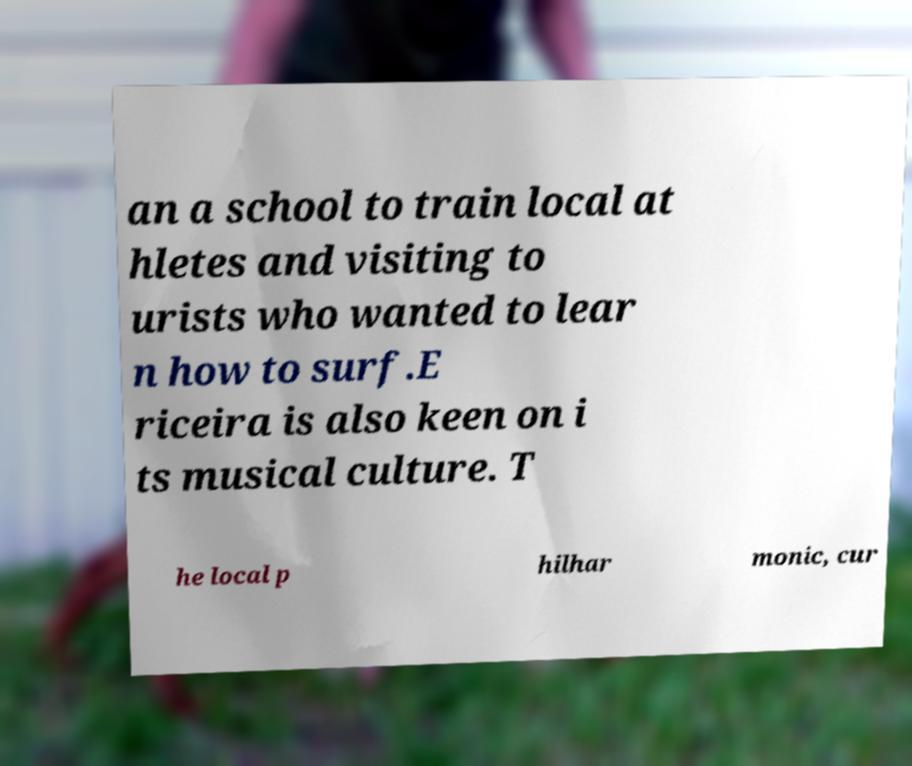Please read and relay the text visible in this image. What does it say? an a school to train local at hletes and visiting to urists who wanted to lear n how to surf.E riceira is also keen on i ts musical culture. T he local p hilhar monic, cur 